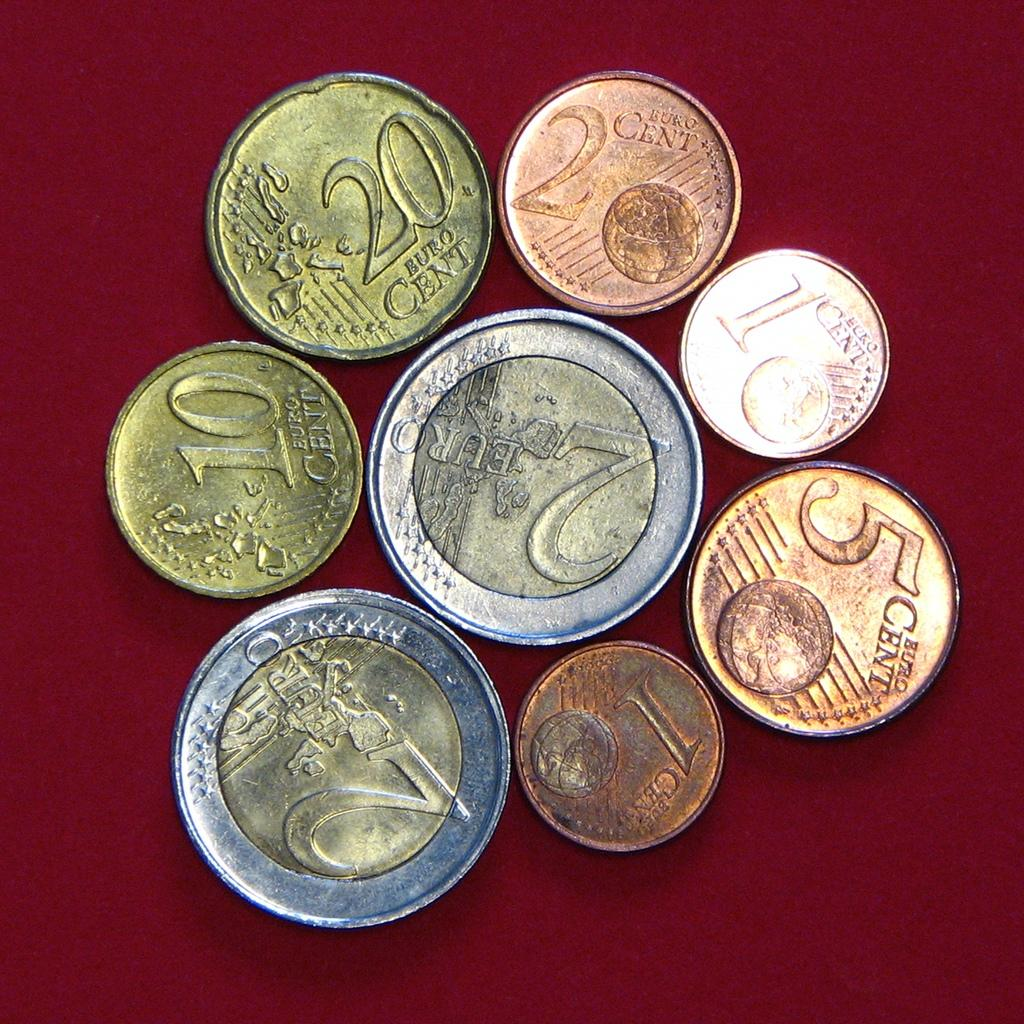<image>
Provide a brief description of the given image. Several coins ranging from 1 Euro cent to 2 Euro 